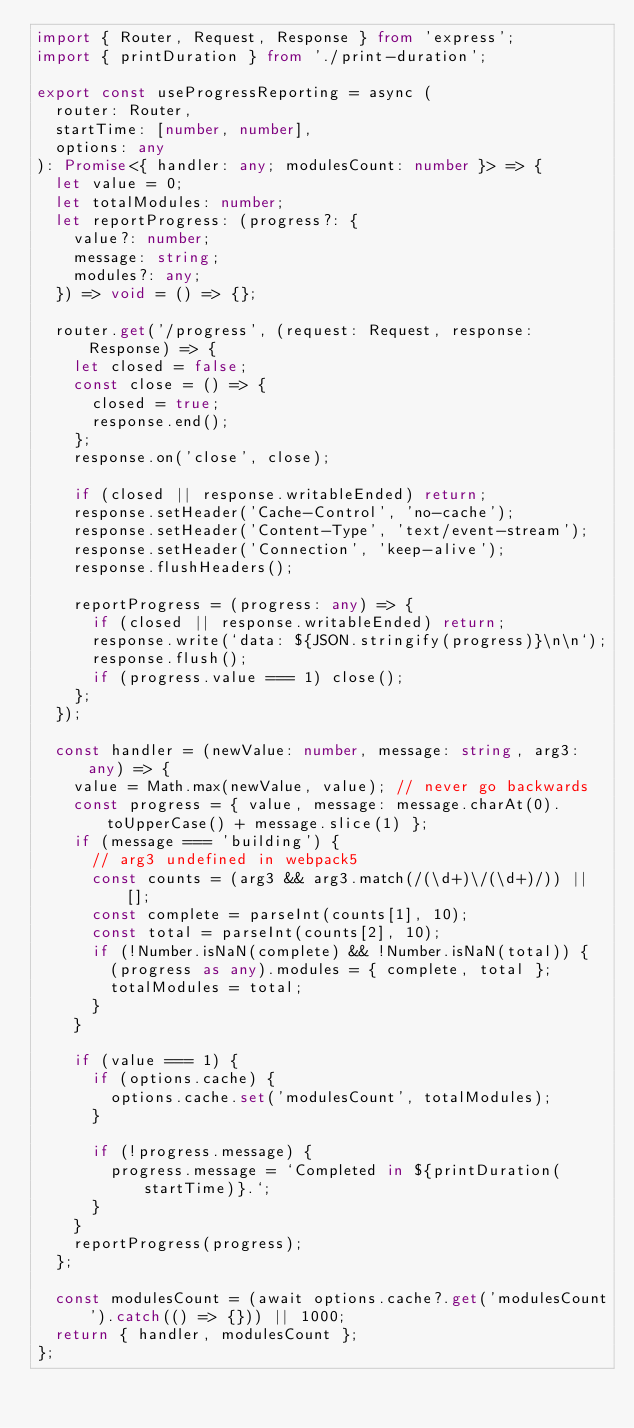<code> <loc_0><loc_0><loc_500><loc_500><_TypeScript_>import { Router, Request, Response } from 'express';
import { printDuration } from './print-duration';

export const useProgressReporting = async (
  router: Router,
  startTime: [number, number],
  options: any
): Promise<{ handler: any; modulesCount: number }> => {
  let value = 0;
  let totalModules: number;
  let reportProgress: (progress?: {
    value?: number;
    message: string;
    modules?: any;
  }) => void = () => {};

  router.get('/progress', (request: Request, response: Response) => {
    let closed = false;
    const close = () => {
      closed = true;
      response.end();
    };
    response.on('close', close);

    if (closed || response.writableEnded) return;
    response.setHeader('Cache-Control', 'no-cache');
    response.setHeader('Content-Type', 'text/event-stream');
    response.setHeader('Connection', 'keep-alive');
    response.flushHeaders();

    reportProgress = (progress: any) => {
      if (closed || response.writableEnded) return;
      response.write(`data: ${JSON.stringify(progress)}\n\n`);
      response.flush();
      if (progress.value === 1) close();
    };
  });

  const handler = (newValue: number, message: string, arg3: any) => {
    value = Math.max(newValue, value); // never go backwards
    const progress = { value, message: message.charAt(0).toUpperCase() + message.slice(1) };
    if (message === 'building') {
      // arg3 undefined in webpack5
      const counts = (arg3 && arg3.match(/(\d+)\/(\d+)/)) || [];
      const complete = parseInt(counts[1], 10);
      const total = parseInt(counts[2], 10);
      if (!Number.isNaN(complete) && !Number.isNaN(total)) {
        (progress as any).modules = { complete, total };
        totalModules = total;
      }
    }

    if (value === 1) {
      if (options.cache) {
        options.cache.set('modulesCount', totalModules);
      }

      if (!progress.message) {
        progress.message = `Completed in ${printDuration(startTime)}.`;
      }
    }
    reportProgress(progress);
  };

  const modulesCount = (await options.cache?.get('modulesCount').catch(() => {})) || 1000;
  return { handler, modulesCount };
};
</code> 